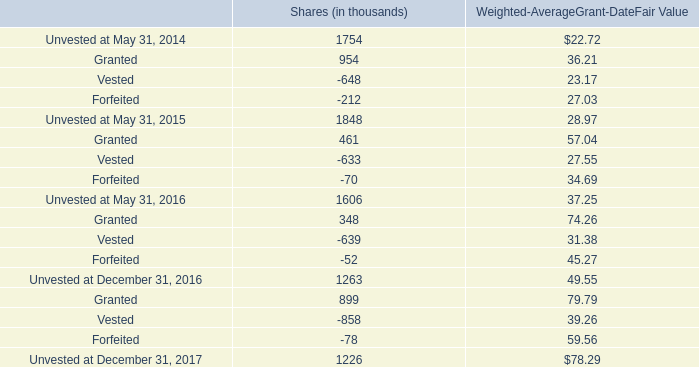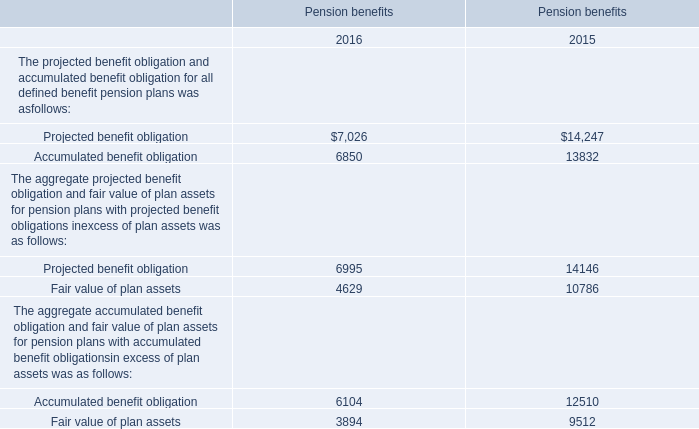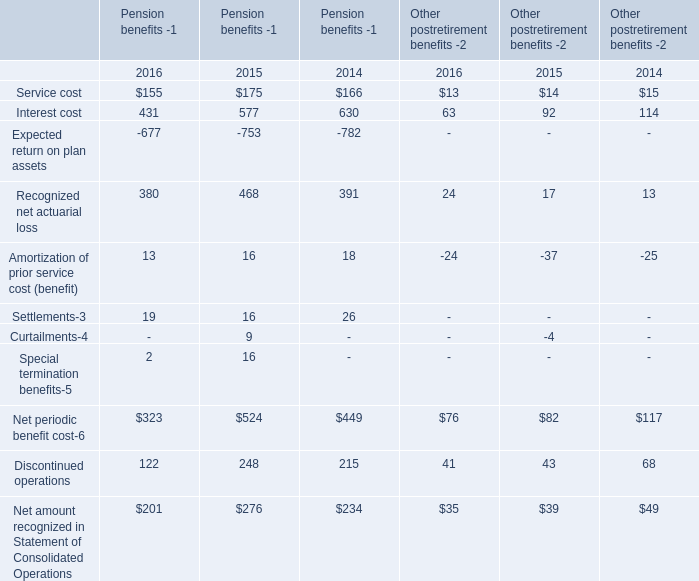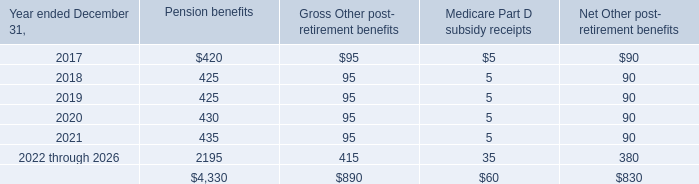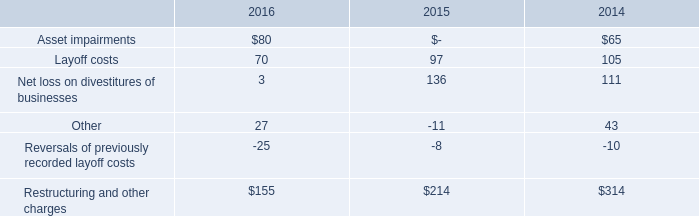what was the change in millions in the total fair value of restricted stock and performance awards vested from 2016 to 2017? 
Computations: (33.7 - 20.0)
Answer: 13.7. 